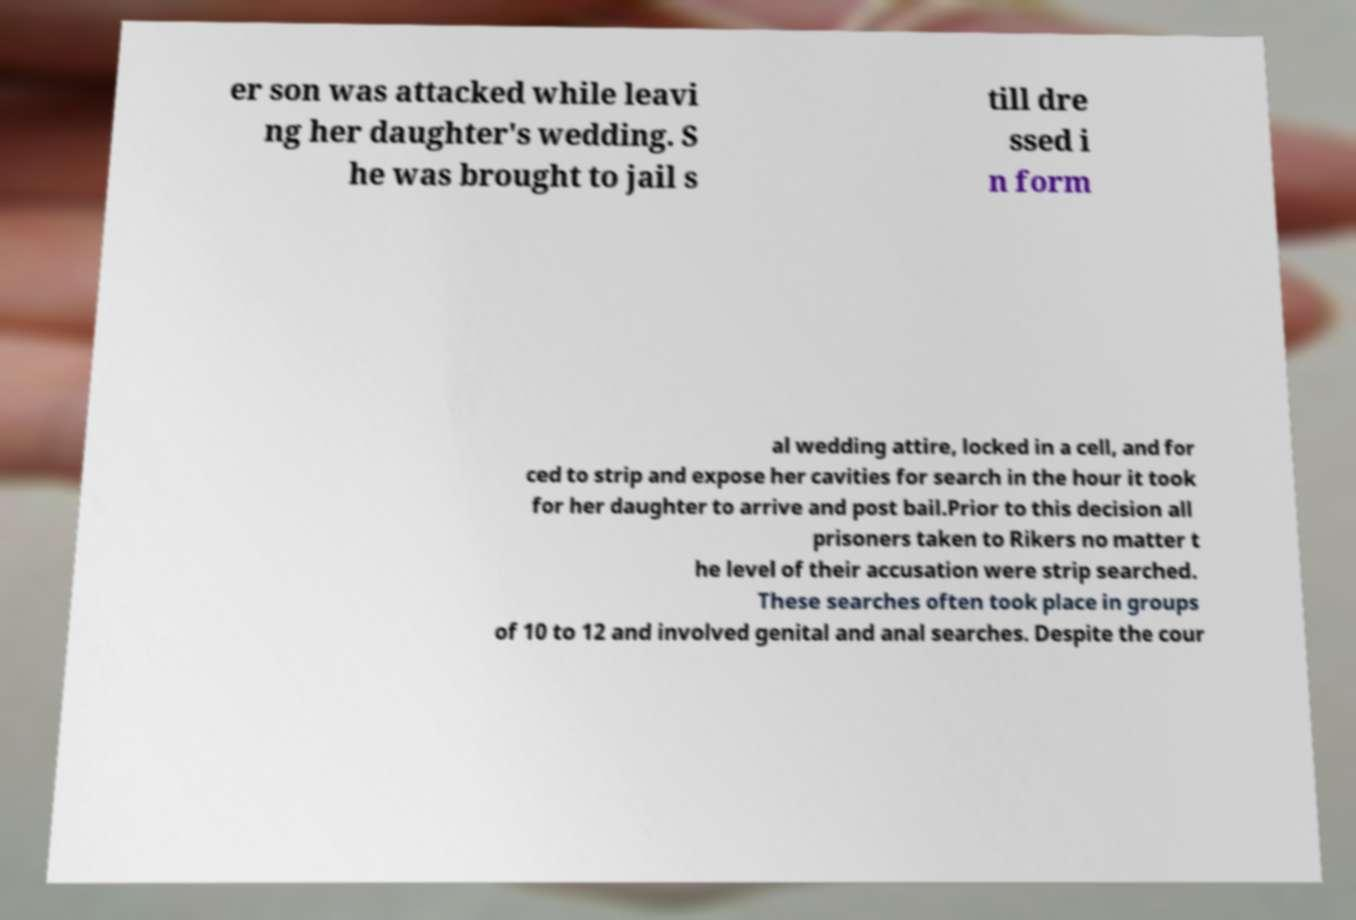What messages or text are displayed in this image? I need them in a readable, typed format. er son was attacked while leavi ng her daughter's wedding. S he was brought to jail s till dre ssed i n form al wedding attire, locked in a cell, and for ced to strip and expose her cavities for search in the hour it took for her daughter to arrive and post bail.Prior to this decision all prisoners taken to Rikers no matter t he level of their accusation were strip searched. These searches often took place in groups of 10 to 12 and involved genital and anal searches. Despite the cour 